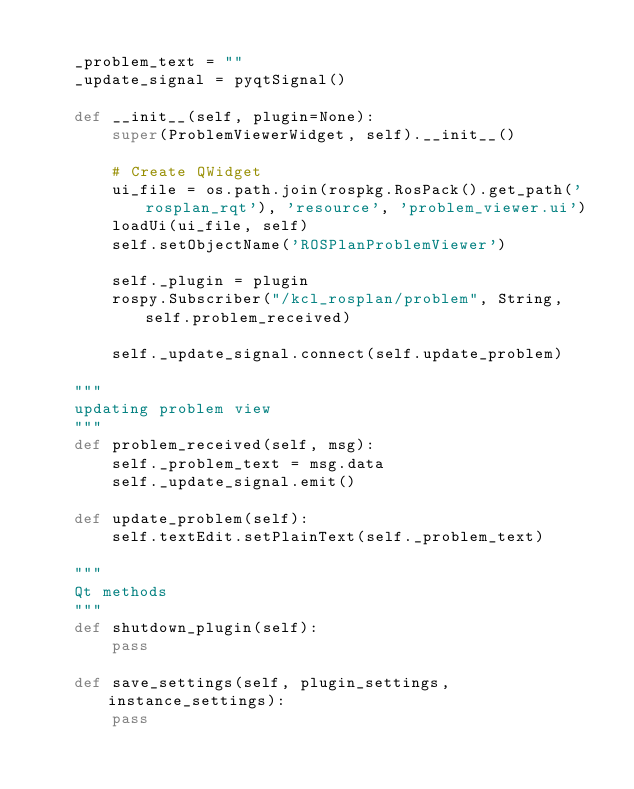Convert code to text. <code><loc_0><loc_0><loc_500><loc_500><_Python_>
    _problem_text = ""
    _update_signal = pyqtSignal()

    def __init__(self, plugin=None):
        super(ProblemViewerWidget, self).__init__()

        # Create QWidget
        ui_file = os.path.join(rospkg.RosPack().get_path('rosplan_rqt'), 'resource', 'problem_viewer.ui')
        loadUi(ui_file, self)
        self.setObjectName('ROSPlanProblemViewer')

        self._plugin = plugin
        rospy.Subscriber("/kcl_rosplan/problem", String, self.problem_received)

        self._update_signal.connect(self.update_problem)

    """
    updating problem view
    """
    def problem_received(self, msg):
        self._problem_text = msg.data
        self._update_signal.emit()

    def update_problem(self):
        self.textEdit.setPlainText(self._problem_text)

    """
    Qt methods
    """ 
    def shutdown_plugin(self):
        pass

    def save_settings(self, plugin_settings, instance_settings):
        pass
</code> 